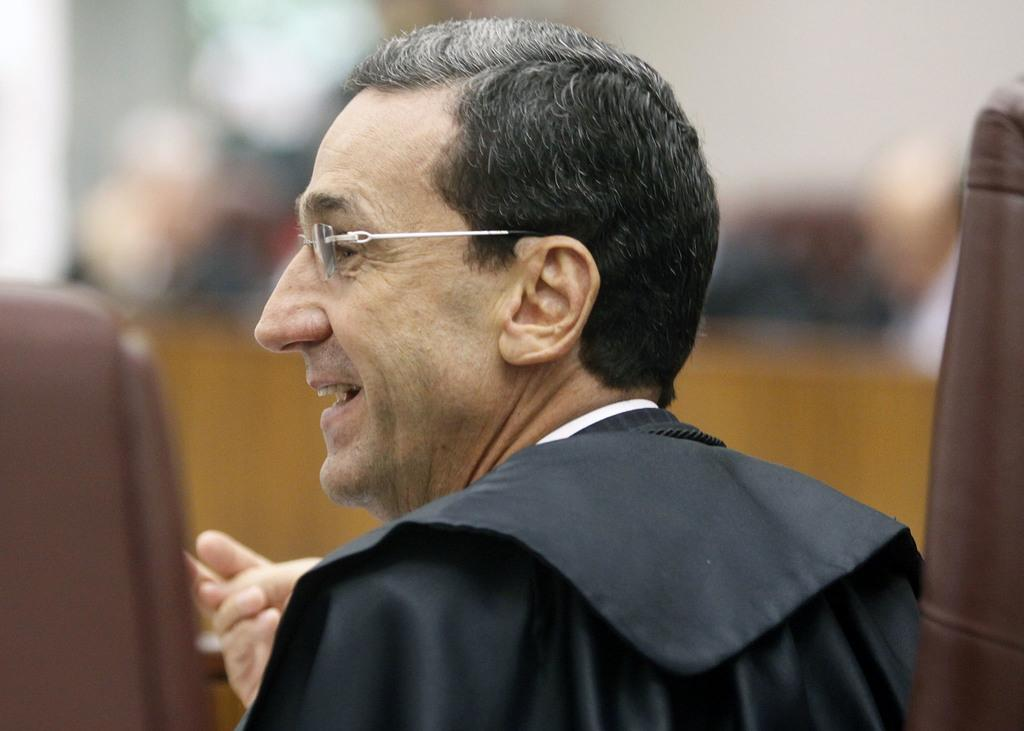What is the main subject of the image? There is a person in the image. Can you describe the person's appearance? The person is wearing glasses. What can be observed about the background of the image? The background of the image is blurred. How many vases are present in the image? There are no vases present in the image. What country is depicted in the background of the image? The background of the image is blurred, and no country is visible or mentioned. 